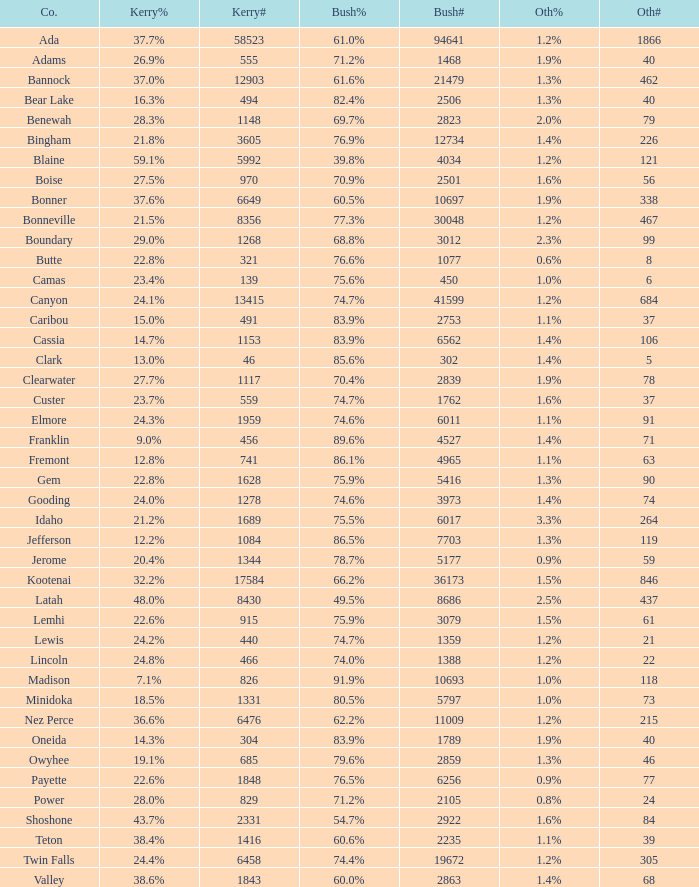How many people voted for Kerry in the county where 8 voted for others? 321.0. 